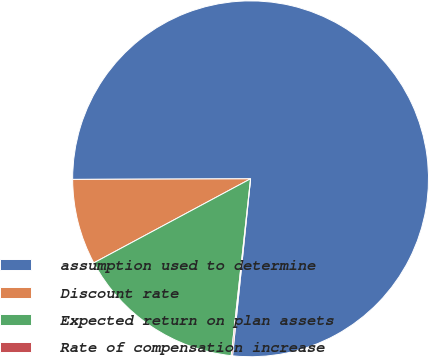<chart> <loc_0><loc_0><loc_500><loc_500><pie_chart><fcel>assumption used to determine<fcel>Discount rate<fcel>Expected return on plan assets<fcel>Rate of compensation increase<nl><fcel>76.67%<fcel>7.78%<fcel>15.43%<fcel>0.12%<nl></chart> 